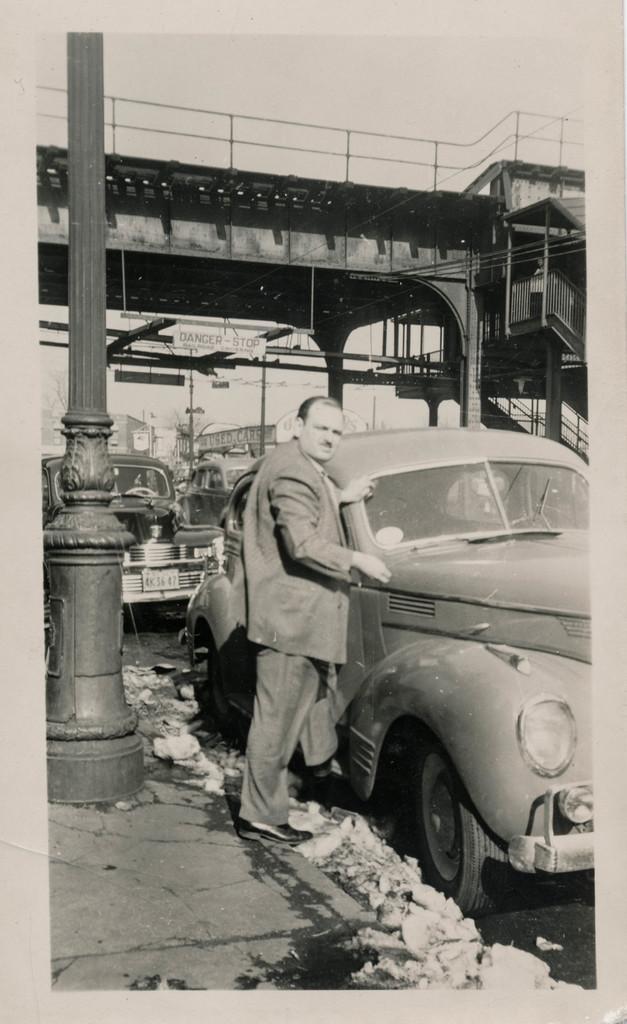Please provide a concise description of this image. This image is a black and white image. This image is an edited image. This image taken outdoors. At the top of the image there is the sky. At the bottom of the image there is a road and it is untidy. On the left side of the image there is a pillar. In the background there is a bridge. There are few buildings. A car is parked on the road. On the right side of the image a car is parked on the road. In the middle of the image a man is standing on the road. 